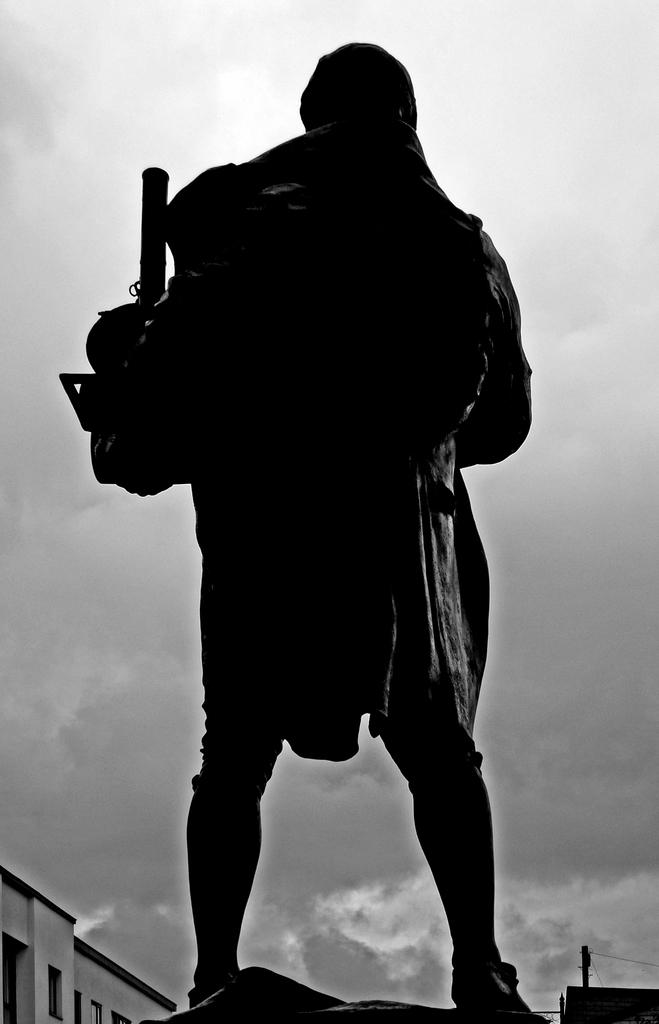What is the color scheme of the image? The image is black and white. What is the person in the image holding? There is a person holding an object in the image. What type of structure can be seen in the image? There is a building in the image. What other objects can be seen in the image? There is a pole and wires in the image. What is visible in the background of the image? The sky is visible in the image, and clouds are present in the sky. What type of plough is being used to answer questions in the image? There is no plough present in the image, and no one is answering questions. 